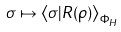Convert formula to latex. <formula><loc_0><loc_0><loc_500><loc_500>\sigma \mapsto \left \langle \sigma | R ( \rho ) \right \rangle _ { \Phi _ { H } }</formula> 